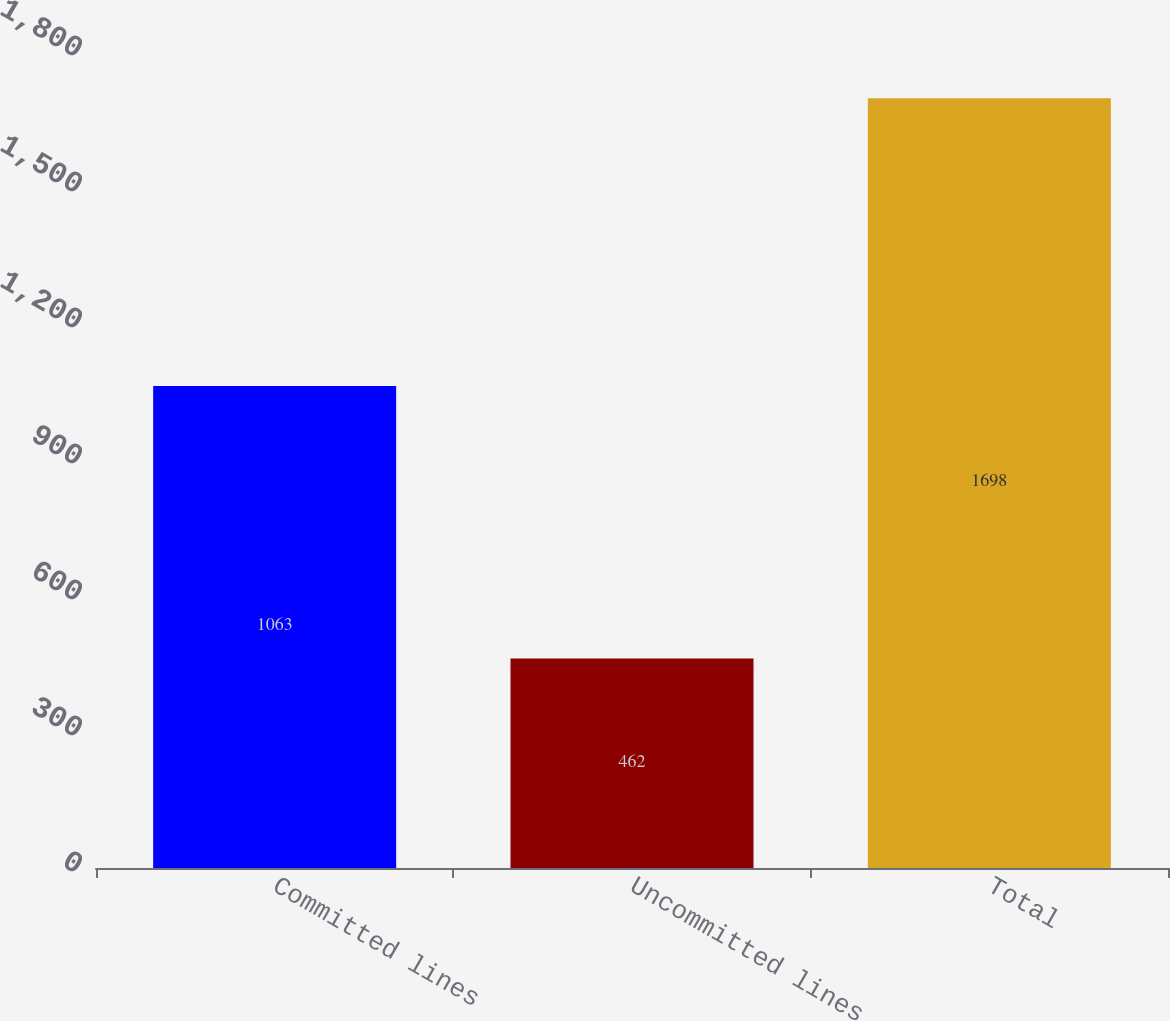<chart> <loc_0><loc_0><loc_500><loc_500><bar_chart><fcel>Committed lines<fcel>Uncommitted lines<fcel>Total<nl><fcel>1063<fcel>462<fcel>1698<nl></chart> 